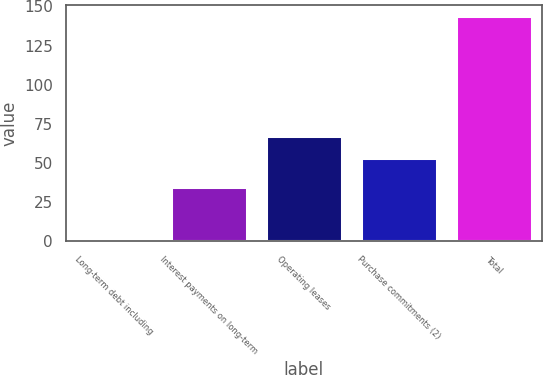Convert chart. <chart><loc_0><loc_0><loc_500><loc_500><bar_chart><fcel>Long-term debt including<fcel>Interest payments on long-term<fcel>Operating leases<fcel>Purchase commitments (2)<fcel>Total<nl><fcel>1.7<fcel>34.7<fcel>67.21<fcel>53<fcel>143.8<nl></chart> 